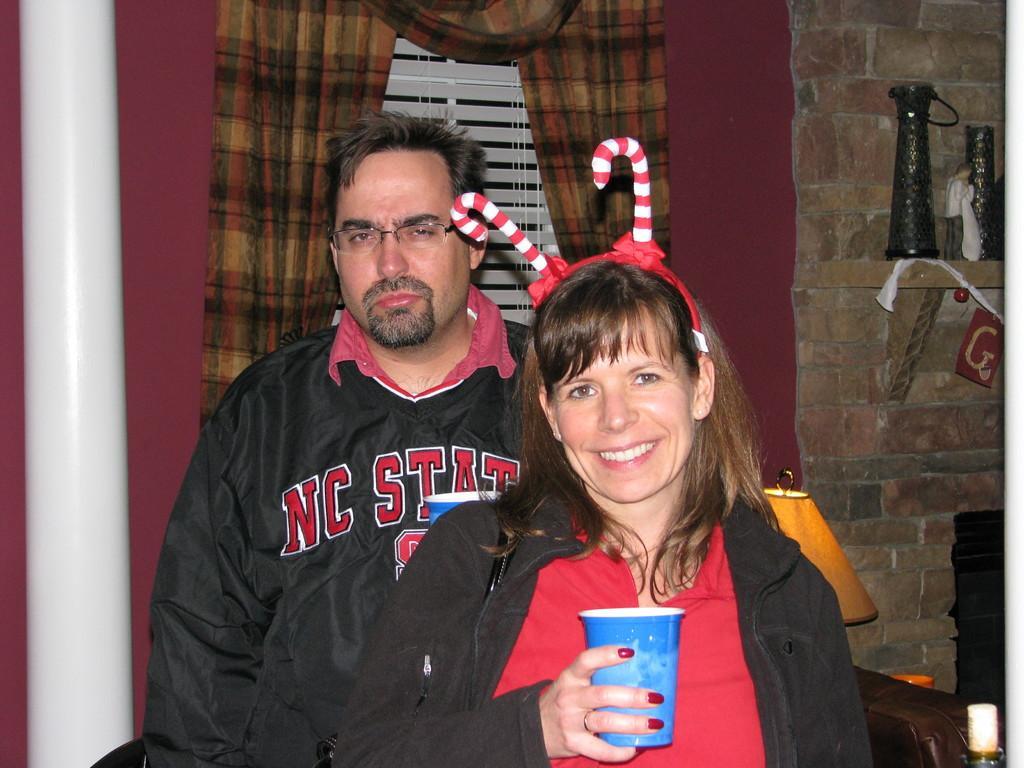Can you describe this image briefly? In the background we can see a window blind, curtain, wall. We can see objects placed on the rack. In this picture we can see a man wearing spectacles and a woman is holding a glass. On the left side of the picture we can see a white pole and on the right side of the picture we can see few objects. 